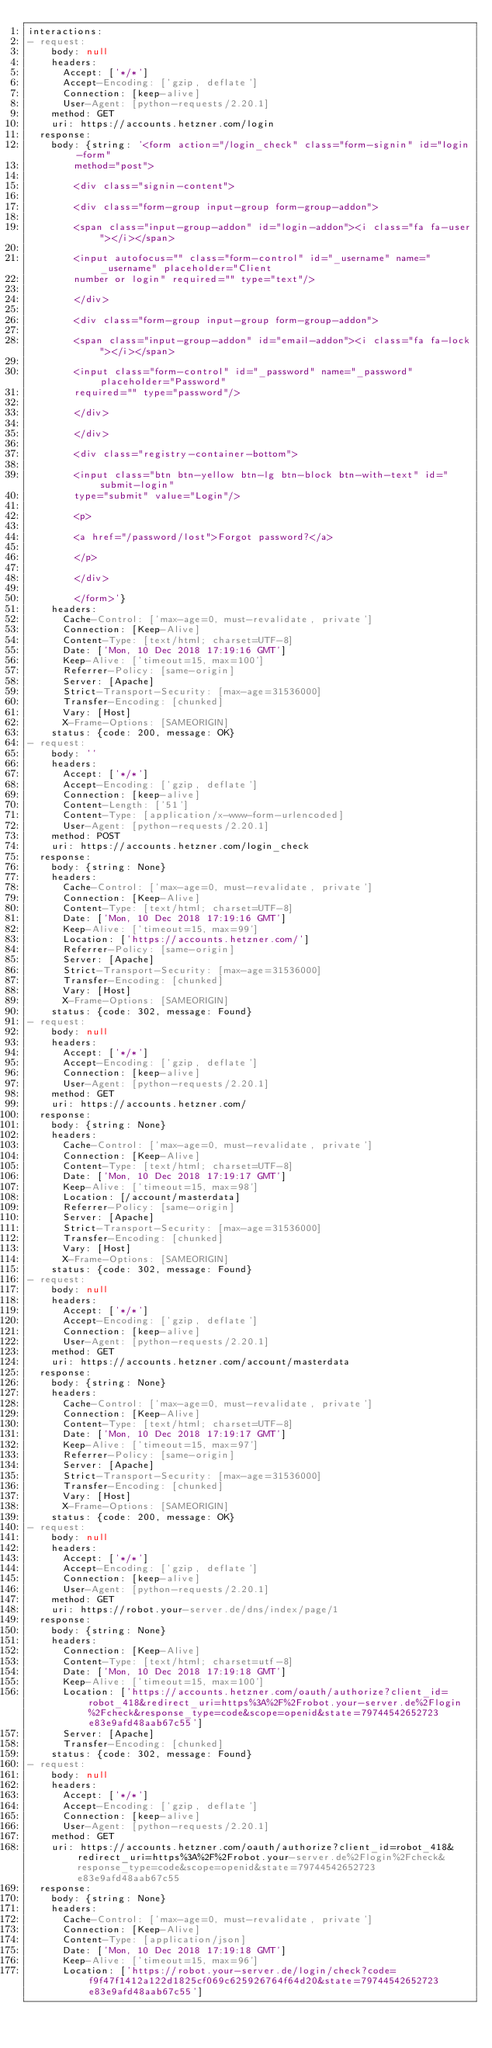Convert code to text. <code><loc_0><loc_0><loc_500><loc_500><_YAML_>interactions:
- request:
    body: null
    headers:
      Accept: ['*/*']
      Accept-Encoding: ['gzip, deflate']
      Connection: [keep-alive]
      User-Agent: [python-requests/2.20.1]
    method: GET
    uri: https://accounts.hetzner.com/login
  response:
    body: {string: '<form action="/login_check" class="form-signin" id="login-form"
        method="post">

        <div class="signin-content">

        <div class="form-group input-group form-group-addon">

        <span class="input-group-addon" id="login-addon"><i class="fa fa-user"></i></span>

        <input autofocus="" class="form-control" id="_username" name="_username" placeholder="Client
        number or login" required="" type="text"/>

        </div>

        <div class="form-group input-group form-group-addon">

        <span class="input-group-addon" id="email-addon"><i class="fa fa-lock"></i></span>

        <input class="form-control" id="_password" name="_password" placeholder="Password"
        required="" type="password"/>

        </div>

        </div>

        <div class="registry-container-bottom">

        <input class="btn btn-yellow btn-lg btn-block btn-with-text" id="submit-login"
        type="submit" value="Login"/>

        <p>

        <a href="/password/lost">Forgot password?</a>

        </p>

        </div>

        </form>'}
    headers:
      Cache-Control: ['max-age=0, must-revalidate, private']
      Connection: [Keep-Alive]
      Content-Type: [text/html; charset=UTF-8]
      Date: ['Mon, 10 Dec 2018 17:19:16 GMT']
      Keep-Alive: ['timeout=15, max=100']
      Referrer-Policy: [same-origin]
      Server: [Apache]
      Strict-Transport-Security: [max-age=31536000]
      Transfer-Encoding: [chunked]
      Vary: [Host]
      X-Frame-Options: [SAMEORIGIN]
    status: {code: 200, message: OK}
- request:
    body: ''
    headers:
      Accept: ['*/*']
      Accept-Encoding: ['gzip, deflate']
      Connection: [keep-alive]
      Content-Length: ['51']
      Content-Type: [application/x-www-form-urlencoded]
      User-Agent: [python-requests/2.20.1]
    method: POST
    uri: https://accounts.hetzner.com/login_check
  response:
    body: {string: None}
    headers:
      Cache-Control: ['max-age=0, must-revalidate, private']
      Connection: [Keep-Alive]
      Content-Type: [text/html; charset=UTF-8]
      Date: ['Mon, 10 Dec 2018 17:19:16 GMT']
      Keep-Alive: ['timeout=15, max=99']
      Location: ['https://accounts.hetzner.com/']
      Referrer-Policy: [same-origin]
      Server: [Apache]
      Strict-Transport-Security: [max-age=31536000]
      Transfer-Encoding: [chunked]
      Vary: [Host]
      X-Frame-Options: [SAMEORIGIN]
    status: {code: 302, message: Found}
- request:
    body: null
    headers:
      Accept: ['*/*']
      Accept-Encoding: ['gzip, deflate']
      Connection: [keep-alive]
      User-Agent: [python-requests/2.20.1]
    method: GET
    uri: https://accounts.hetzner.com/
  response:
    body: {string: None}
    headers:
      Cache-Control: ['max-age=0, must-revalidate, private']
      Connection: [Keep-Alive]
      Content-Type: [text/html; charset=UTF-8]
      Date: ['Mon, 10 Dec 2018 17:19:17 GMT']
      Keep-Alive: ['timeout=15, max=98']
      Location: [/account/masterdata]
      Referrer-Policy: [same-origin]
      Server: [Apache]
      Strict-Transport-Security: [max-age=31536000]
      Transfer-Encoding: [chunked]
      Vary: [Host]
      X-Frame-Options: [SAMEORIGIN]
    status: {code: 302, message: Found}
- request:
    body: null
    headers:
      Accept: ['*/*']
      Accept-Encoding: ['gzip, deflate']
      Connection: [keep-alive]
      User-Agent: [python-requests/2.20.1]
    method: GET
    uri: https://accounts.hetzner.com/account/masterdata
  response:
    body: {string: None}
    headers:
      Cache-Control: ['max-age=0, must-revalidate, private']
      Connection: [Keep-Alive]
      Content-Type: [text/html; charset=UTF-8]
      Date: ['Mon, 10 Dec 2018 17:19:17 GMT']
      Keep-Alive: ['timeout=15, max=97']
      Referrer-Policy: [same-origin]
      Server: [Apache]
      Strict-Transport-Security: [max-age=31536000]
      Transfer-Encoding: [chunked]
      Vary: [Host]
      X-Frame-Options: [SAMEORIGIN]
    status: {code: 200, message: OK}
- request:
    body: null
    headers:
      Accept: ['*/*']
      Accept-Encoding: ['gzip, deflate']
      Connection: [keep-alive]
      User-Agent: [python-requests/2.20.1]
    method: GET
    uri: https://robot.your-server.de/dns/index/page/1
  response:
    body: {string: None}
    headers:
      Connection: [Keep-Alive]
      Content-Type: [text/html; charset=utf-8]
      Date: ['Mon, 10 Dec 2018 17:19:18 GMT']
      Keep-Alive: ['timeout=15, max=100']
      Location: ['https://accounts.hetzner.com/oauth/authorize?client_id=robot_418&redirect_uri=https%3A%2F%2Frobot.your-server.de%2Flogin%2Fcheck&response_type=code&scope=openid&state=79744542652723e83e9afd48aab67c55']
      Server: [Apache]
      Transfer-Encoding: [chunked]
    status: {code: 302, message: Found}
- request:
    body: null
    headers:
      Accept: ['*/*']
      Accept-Encoding: ['gzip, deflate']
      Connection: [keep-alive]
      User-Agent: [python-requests/2.20.1]
    method: GET
    uri: https://accounts.hetzner.com/oauth/authorize?client_id=robot_418&redirect_uri=https%3A%2F%2Frobot.your-server.de%2Flogin%2Fcheck&response_type=code&scope=openid&state=79744542652723e83e9afd48aab67c55
  response:
    body: {string: None}
    headers:
      Cache-Control: ['max-age=0, must-revalidate, private']
      Connection: [Keep-Alive]
      Content-Type: [application/json]
      Date: ['Mon, 10 Dec 2018 17:19:18 GMT']
      Keep-Alive: ['timeout=15, max=96']
      Location: ['https://robot.your-server.de/login/check?code=f9f47f1412a122d1825cf069c625926764f64d20&state=79744542652723e83e9afd48aab67c55']</code> 